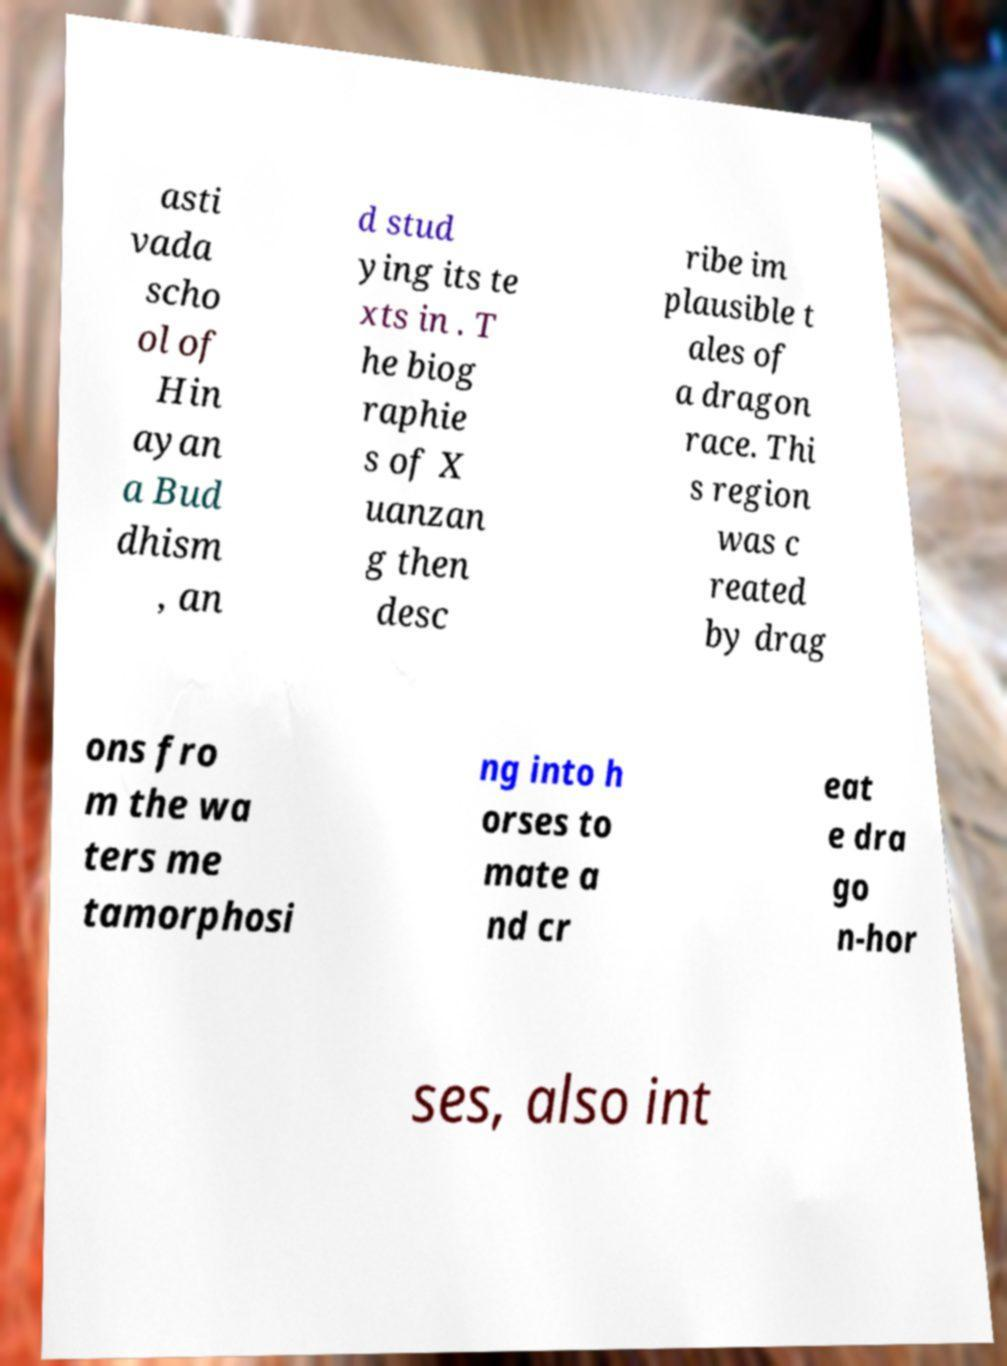Can you accurately transcribe the text from the provided image for me? asti vada scho ol of Hin ayan a Bud dhism , an d stud ying its te xts in . T he biog raphie s of X uanzan g then desc ribe im plausible t ales of a dragon race. Thi s region was c reated by drag ons fro m the wa ters me tamorphosi ng into h orses to mate a nd cr eat e dra go n-hor ses, also int 